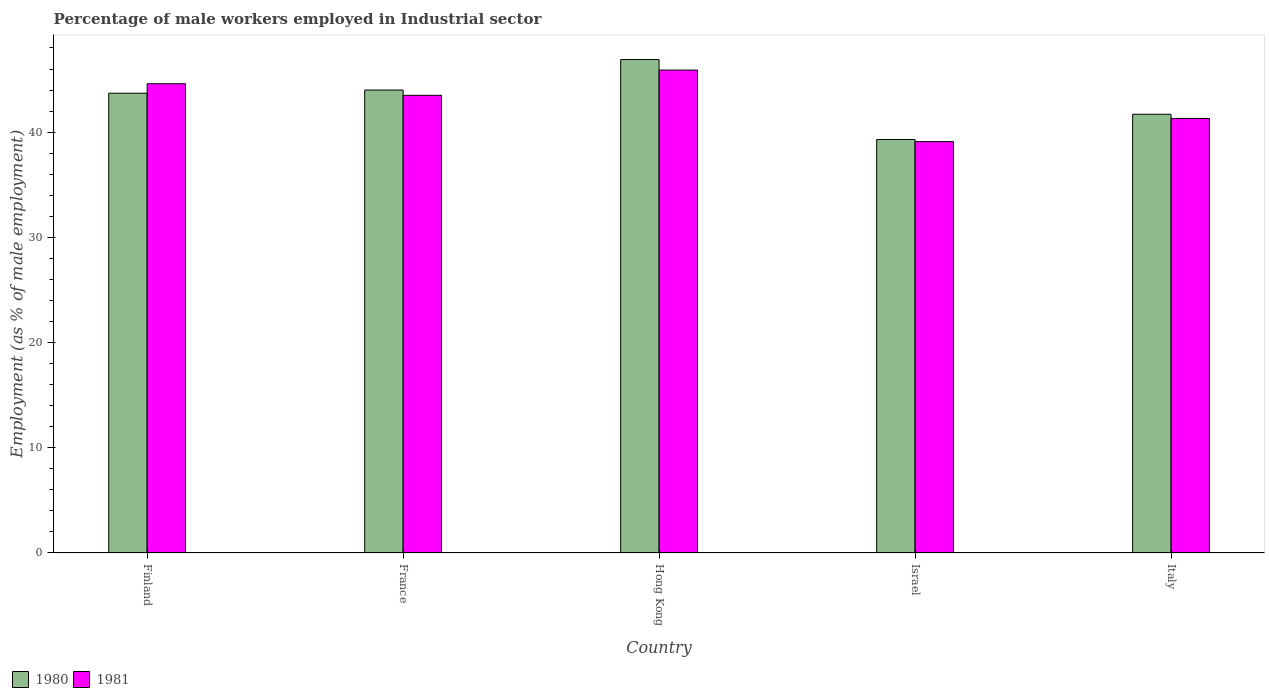How many groups of bars are there?
Your response must be concise. 5. Are the number of bars per tick equal to the number of legend labels?
Keep it short and to the point. Yes. Are the number of bars on each tick of the X-axis equal?
Your answer should be very brief. Yes. What is the percentage of male workers employed in Industrial sector in 1981 in Hong Kong?
Offer a terse response. 45.9. Across all countries, what is the maximum percentage of male workers employed in Industrial sector in 1980?
Offer a very short reply. 46.9. Across all countries, what is the minimum percentage of male workers employed in Industrial sector in 1980?
Keep it short and to the point. 39.3. In which country was the percentage of male workers employed in Industrial sector in 1980 maximum?
Give a very brief answer. Hong Kong. What is the total percentage of male workers employed in Industrial sector in 1981 in the graph?
Your response must be concise. 214.4. What is the difference between the percentage of male workers employed in Industrial sector in 1980 in France and that in Hong Kong?
Offer a very short reply. -2.9. What is the difference between the percentage of male workers employed in Industrial sector in 1980 in Hong Kong and the percentage of male workers employed in Industrial sector in 1981 in Italy?
Your answer should be very brief. 5.6. What is the average percentage of male workers employed in Industrial sector in 1980 per country?
Provide a succinct answer. 43.12. What is the difference between the percentage of male workers employed in Industrial sector of/in 1980 and percentage of male workers employed in Industrial sector of/in 1981 in Israel?
Offer a very short reply. 0.2. In how many countries, is the percentage of male workers employed in Industrial sector in 1981 greater than 14 %?
Offer a terse response. 5. What is the ratio of the percentage of male workers employed in Industrial sector in 1980 in Finland to that in Hong Kong?
Ensure brevity in your answer.  0.93. Is the percentage of male workers employed in Industrial sector in 1980 in Hong Kong less than that in Italy?
Offer a terse response. No. Is the difference between the percentage of male workers employed in Industrial sector in 1980 in Hong Kong and Israel greater than the difference between the percentage of male workers employed in Industrial sector in 1981 in Hong Kong and Israel?
Your response must be concise. Yes. What is the difference between the highest and the second highest percentage of male workers employed in Industrial sector in 1981?
Ensure brevity in your answer.  -1.1. What is the difference between the highest and the lowest percentage of male workers employed in Industrial sector in 1980?
Offer a terse response. 7.6. In how many countries, is the percentage of male workers employed in Industrial sector in 1981 greater than the average percentage of male workers employed in Industrial sector in 1981 taken over all countries?
Your response must be concise. 3. Is the sum of the percentage of male workers employed in Industrial sector in 1981 in Israel and Italy greater than the maximum percentage of male workers employed in Industrial sector in 1980 across all countries?
Provide a succinct answer. Yes. What does the 1st bar from the left in Italy represents?
Make the answer very short. 1980. What is the difference between two consecutive major ticks on the Y-axis?
Your response must be concise. 10. Does the graph contain grids?
Your answer should be compact. No. How many legend labels are there?
Offer a very short reply. 2. How are the legend labels stacked?
Offer a terse response. Horizontal. What is the title of the graph?
Give a very brief answer. Percentage of male workers employed in Industrial sector. Does "1993" appear as one of the legend labels in the graph?
Ensure brevity in your answer.  No. What is the label or title of the Y-axis?
Your answer should be very brief. Employment (as % of male employment). What is the Employment (as % of male employment) in 1980 in Finland?
Ensure brevity in your answer.  43.7. What is the Employment (as % of male employment) of 1981 in Finland?
Provide a short and direct response. 44.6. What is the Employment (as % of male employment) in 1981 in France?
Make the answer very short. 43.5. What is the Employment (as % of male employment) of 1980 in Hong Kong?
Keep it short and to the point. 46.9. What is the Employment (as % of male employment) of 1981 in Hong Kong?
Give a very brief answer. 45.9. What is the Employment (as % of male employment) of 1980 in Israel?
Your response must be concise. 39.3. What is the Employment (as % of male employment) in 1981 in Israel?
Provide a succinct answer. 39.1. What is the Employment (as % of male employment) in 1980 in Italy?
Give a very brief answer. 41.7. What is the Employment (as % of male employment) in 1981 in Italy?
Provide a short and direct response. 41.3. Across all countries, what is the maximum Employment (as % of male employment) in 1980?
Offer a terse response. 46.9. Across all countries, what is the maximum Employment (as % of male employment) of 1981?
Provide a succinct answer. 45.9. Across all countries, what is the minimum Employment (as % of male employment) of 1980?
Give a very brief answer. 39.3. Across all countries, what is the minimum Employment (as % of male employment) of 1981?
Provide a succinct answer. 39.1. What is the total Employment (as % of male employment) of 1980 in the graph?
Offer a terse response. 215.6. What is the total Employment (as % of male employment) in 1981 in the graph?
Give a very brief answer. 214.4. What is the difference between the Employment (as % of male employment) in 1980 in Finland and that in France?
Offer a terse response. -0.3. What is the difference between the Employment (as % of male employment) of 1981 in Finland and that in Hong Kong?
Your answer should be very brief. -1.3. What is the difference between the Employment (as % of male employment) in 1980 in Finland and that in Israel?
Keep it short and to the point. 4.4. What is the difference between the Employment (as % of male employment) of 1981 in Finland and that in Israel?
Provide a succinct answer. 5.5. What is the difference between the Employment (as % of male employment) in 1980 in Finland and that in Italy?
Your answer should be compact. 2. What is the difference between the Employment (as % of male employment) in 1981 in Finland and that in Italy?
Your answer should be compact. 3.3. What is the difference between the Employment (as % of male employment) in 1980 in Hong Kong and that in Israel?
Give a very brief answer. 7.6. What is the difference between the Employment (as % of male employment) of 1981 in Hong Kong and that in Israel?
Ensure brevity in your answer.  6.8. What is the difference between the Employment (as % of male employment) of 1980 in Hong Kong and that in Italy?
Your answer should be very brief. 5.2. What is the difference between the Employment (as % of male employment) in 1981 in Hong Kong and that in Italy?
Keep it short and to the point. 4.6. What is the difference between the Employment (as % of male employment) of 1980 in Finland and the Employment (as % of male employment) of 1981 in Israel?
Your answer should be very brief. 4.6. What is the difference between the Employment (as % of male employment) of 1980 in France and the Employment (as % of male employment) of 1981 in Israel?
Your answer should be very brief. 4.9. What is the average Employment (as % of male employment) in 1980 per country?
Your response must be concise. 43.12. What is the average Employment (as % of male employment) of 1981 per country?
Your answer should be compact. 42.88. What is the difference between the Employment (as % of male employment) in 1980 and Employment (as % of male employment) in 1981 in Hong Kong?
Provide a short and direct response. 1. What is the difference between the Employment (as % of male employment) in 1980 and Employment (as % of male employment) in 1981 in Israel?
Make the answer very short. 0.2. What is the difference between the Employment (as % of male employment) of 1980 and Employment (as % of male employment) of 1981 in Italy?
Ensure brevity in your answer.  0.4. What is the ratio of the Employment (as % of male employment) in 1981 in Finland to that in France?
Offer a very short reply. 1.03. What is the ratio of the Employment (as % of male employment) of 1980 in Finland to that in Hong Kong?
Ensure brevity in your answer.  0.93. What is the ratio of the Employment (as % of male employment) in 1981 in Finland to that in Hong Kong?
Offer a very short reply. 0.97. What is the ratio of the Employment (as % of male employment) in 1980 in Finland to that in Israel?
Give a very brief answer. 1.11. What is the ratio of the Employment (as % of male employment) of 1981 in Finland to that in Israel?
Keep it short and to the point. 1.14. What is the ratio of the Employment (as % of male employment) of 1980 in Finland to that in Italy?
Make the answer very short. 1.05. What is the ratio of the Employment (as % of male employment) in 1981 in Finland to that in Italy?
Your answer should be very brief. 1.08. What is the ratio of the Employment (as % of male employment) in 1980 in France to that in Hong Kong?
Your response must be concise. 0.94. What is the ratio of the Employment (as % of male employment) of 1981 in France to that in Hong Kong?
Your answer should be compact. 0.95. What is the ratio of the Employment (as % of male employment) of 1980 in France to that in Israel?
Provide a succinct answer. 1.12. What is the ratio of the Employment (as % of male employment) of 1981 in France to that in Israel?
Offer a terse response. 1.11. What is the ratio of the Employment (as % of male employment) of 1980 in France to that in Italy?
Your answer should be very brief. 1.06. What is the ratio of the Employment (as % of male employment) in 1981 in France to that in Italy?
Keep it short and to the point. 1.05. What is the ratio of the Employment (as % of male employment) in 1980 in Hong Kong to that in Israel?
Your answer should be very brief. 1.19. What is the ratio of the Employment (as % of male employment) in 1981 in Hong Kong to that in Israel?
Ensure brevity in your answer.  1.17. What is the ratio of the Employment (as % of male employment) in 1980 in Hong Kong to that in Italy?
Offer a terse response. 1.12. What is the ratio of the Employment (as % of male employment) in 1981 in Hong Kong to that in Italy?
Your response must be concise. 1.11. What is the ratio of the Employment (as % of male employment) in 1980 in Israel to that in Italy?
Offer a very short reply. 0.94. What is the ratio of the Employment (as % of male employment) of 1981 in Israel to that in Italy?
Keep it short and to the point. 0.95. What is the difference between the highest and the second highest Employment (as % of male employment) of 1980?
Ensure brevity in your answer.  2.9. What is the difference between the highest and the lowest Employment (as % of male employment) in 1980?
Your response must be concise. 7.6. 